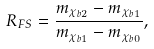<formula> <loc_0><loc_0><loc_500><loc_500>R _ { F S } = \frac { m _ { \chi _ { b 2 } } - m _ { \chi _ { b 1 } } } { m _ { \chi _ { b 1 } } - m _ { \chi _ { b 0 } } } ,</formula> 